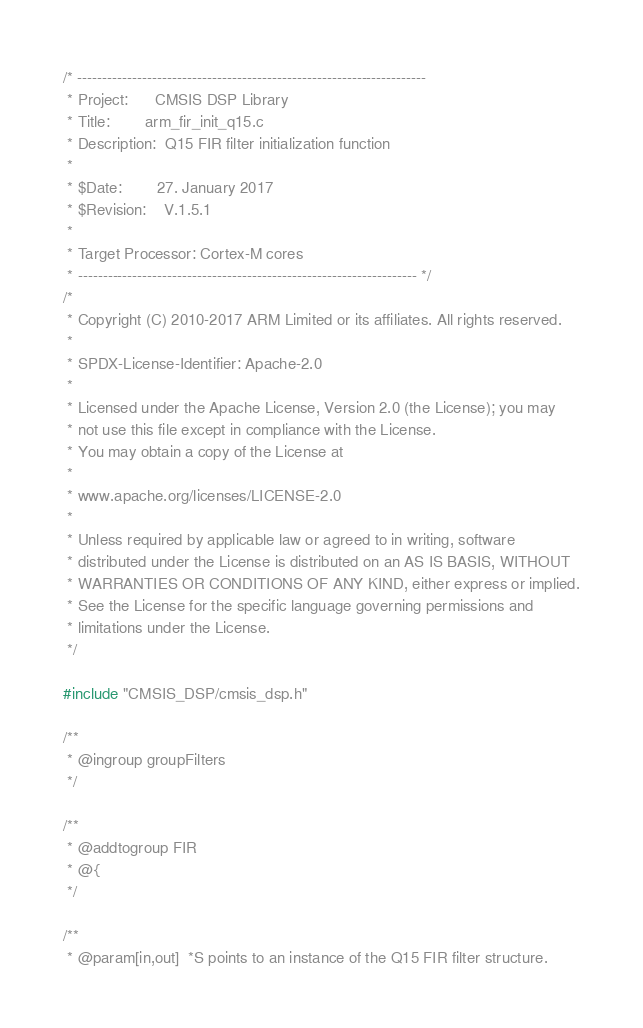<code> <loc_0><loc_0><loc_500><loc_500><_C_>/* ----------------------------------------------------------------------
 * Project:      CMSIS DSP Library
 * Title:        arm_fir_init_q15.c
 * Description:  Q15 FIR filter initialization function
 *
 * $Date:        27. January 2017
 * $Revision:    V.1.5.1
 *
 * Target Processor: Cortex-M cores
 * -------------------------------------------------------------------- */
/*
 * Copyright (C) 2010-2017 ARM Limited or its affiliates. All rights reserved.
 *
 * SPDX-License-Identifier: Apache-2.0
 *
 * Licensed under the Apache License, Version 2.0 (the License); you may
 * not use this file except in compliance with the License.
 * You may obtain a copy of the License at
 *
 * www.apache.org/licenses/LICENSE-2.0
 *
 * Unless required by applicable law or agreed to in writing, software
 * distributed under the License is distributed on an AS IS BASIS, WITHOUT
 * WARRANTIES OR CONDITIONS OF ANY KIND, either express or implied.
 * See the License for the specific language governing permissions and
 * limitations under the License.
 */

#include "CMSIS_DSP/cmsis_dsp.h"

/**
 * @ingroup groupFilters
 */

/**
 * @addtogroup FIR
 * @{
 */

/**
 * @param[in,out]  *S points to an instance of the Q15 FIR filter structure.</code> 